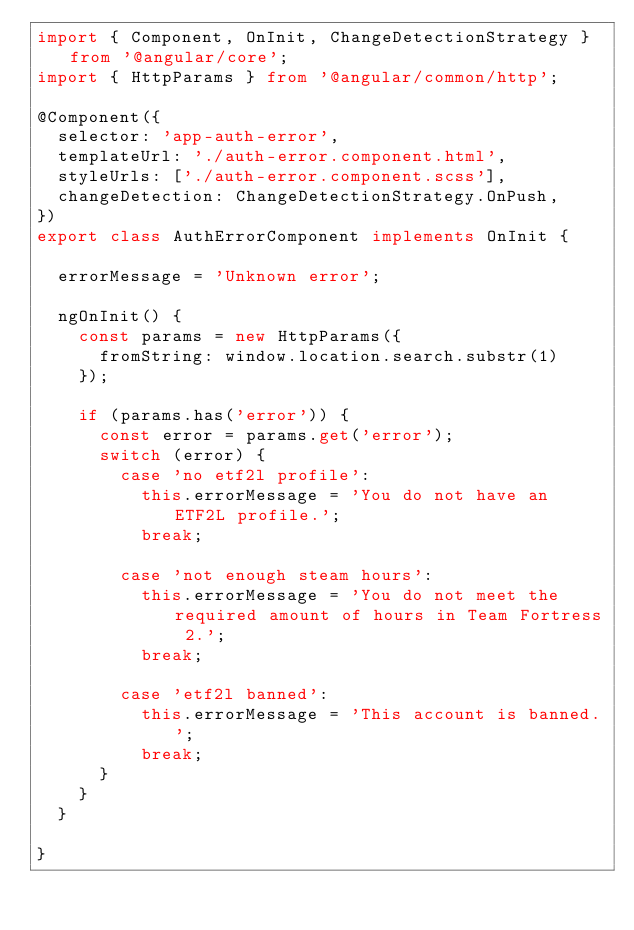Convert code to text. <code><loc_0><loc_0><loc_500><loc_500><_TypeScript_>import { Component, OnInit, ChangeDetectionStrategy } from '@angular/core';
import { HttpParams } from '@angular/common/http';

@Component({
  selector: 'app-auth-error',
  templateUrl: './auth-error.component.html',
  styleUrls: ['./auth-error.component.scss'],
  changeDetection: ChangeDetectionStrategy.OnPush,
})
export class AuthErrorComponent implements OnInit {

  errorMessage = 'Unknown error';

  ngOnInit() {
    const params = new HttpParams({
      fromString: window.location.search.substr(1)
    });

    if (params.has('error')) {
      const error = params.get('error');
      switch (error) {
        case 'no etf2l profile':
          this.errorMessage = 'You do not have an ETF2L profile.';
          break;

        case 'not enough steam hours':
          this.errorMessage = 'You do not meet the required amount of hours in Team Fortress 2.';
          break;

        case 'etf2l banned':
          this.errorMessage = 'This account is banned.';
          break;
      }
    }
  }

}
</code> 